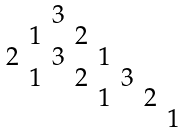Convert formula to latex. <formula><loc_0><loc_0><loc_500><loc_500>\begin{smallmatrix} & & 3 \\ & 1 & & 2 \\ 2 & & 3 & & 1 \\ & 1 & & 2 & & 3 \\ & & & & 1 & & 2 \\ & & & & & & & 1 \end{smallmatrix}</formula> 